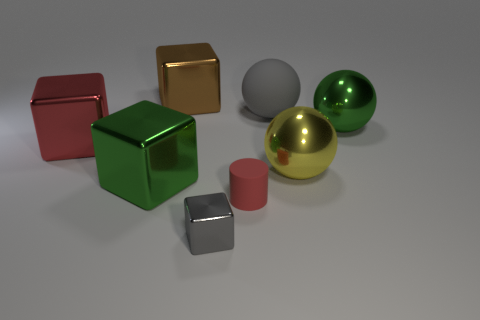Is there anything else that is the same shape as the small red thing?
Ensure brevity in your answer.  No. Is the large rubber object the same color as the tiny block?
Your answer should be very brief. Yes. There is a red matte cylinder that is in front of the block that is left of the big green object that is on the left side of the small gray metallic cube; what is its size?
Your response must be concise. Small. There is a yellow thing that is the same size as the green metal block; what is it made of?
Your answer should be compact. Metal. Is there a red cube of the same size as the matte sphere?
Ensure brevity in your answer.  Yes. There is a metallic cube on the right side of the brown block; is it the same size as the large yellow metallic sphere?
Your answer should be compact. No. There is a large thing that is both on the left side of the big brown shiny thing and on the right side of the large red metallic cube; what is its shape?
Give a very brief answer. Cube. Are there more big green shiny objects that are left of the brown object than small gray matte blocks?
Keep it short and to the point. Yes. The brown cube that is made of the same material as the big yellow ball is what size?
Your answer should be compact. Large. What number of shiny things have the same color as the tiny cylinder?
Your response must be concise. 1. 